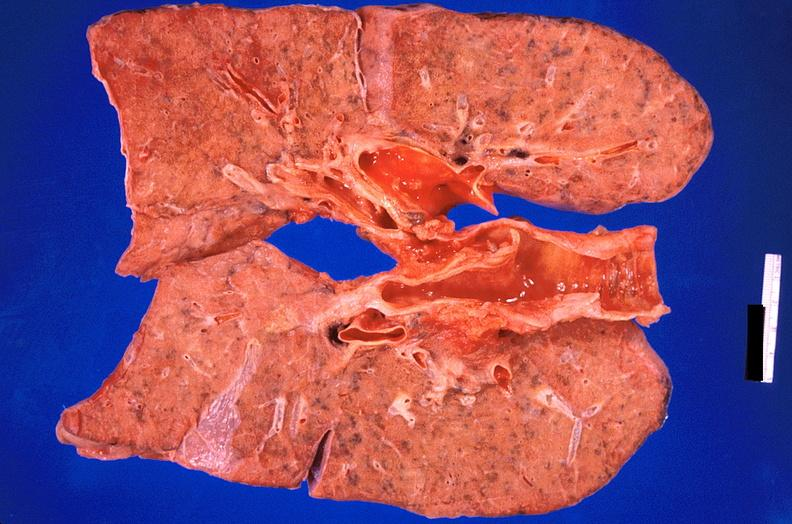what is present?
Answer the question using a single word or phrase. Respiratory 